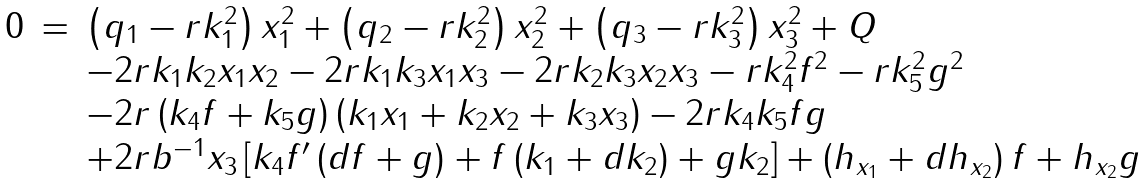<formula> <loc_0><loc_0><loc_500><loc_500>\begin{array} { r c l } 0 & = & \left ( q _ { 1 } - r k _ { 1 } ^ { 2 } \right ) x _ { 1 } ^ { 2 } + \left ( q _ { 2 } - r k _ { 2 } ^ { 2 } \right ) x _ { 2 } ^ { 2 } + \left ( q _ { 3 } - r k _ { 3 } ^ { 2 } \right ) x _ { 3 } ^ { 2 } + Q \\ & & - 2 r k _ { 1 } k _ { 2 } x _ { 1 } x _ { 2 } - 2 r k _ { 1 } k _ { 3 } x _ { 1 } x _ { 3 } - 2 r k _ { 2 } k _ { 3 } x _ { 2 } x _ { 3 } - r k _ { 4 } ^ { 2 } f ^ { 2 } - r k _ { 5 } ^ { 2 } g ^ { 2 } \\ & & - 2 r \left ( k _ { 4 } f + k _ { 5 } g \right ) \left ( k _ { 1 } x _ { 1 } + k _ { 2 } x _ { 2 } + k _ { 3 } x _ { 3 } \right ) - 2 r k _ { 4 } k _ { 5 } f g \\ & & + 2 r b ^ { - 1 } x _ { 3 } \left [ k _ { 4 } f ^ { \prime } \left ( d f + g \right ) + f \left ( k _ { 1 } + d k _ { 2 } \right ) + g k _ { 2 } \right ] + \left ( h _ { x _ { 1 } } + d h _ { x _ { 2 } } \right ) f + h _ { x _ { 2 } } g \end{array}</formula> 